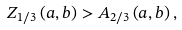Convert formula to latex. <formula><loc_0><loc_0><loc_500><loc_500>Z _ { 1 / 3 } \left ( a , b \right ) > A _ { 2 / 3 } \left ( a , b \right ) ,</formula> 